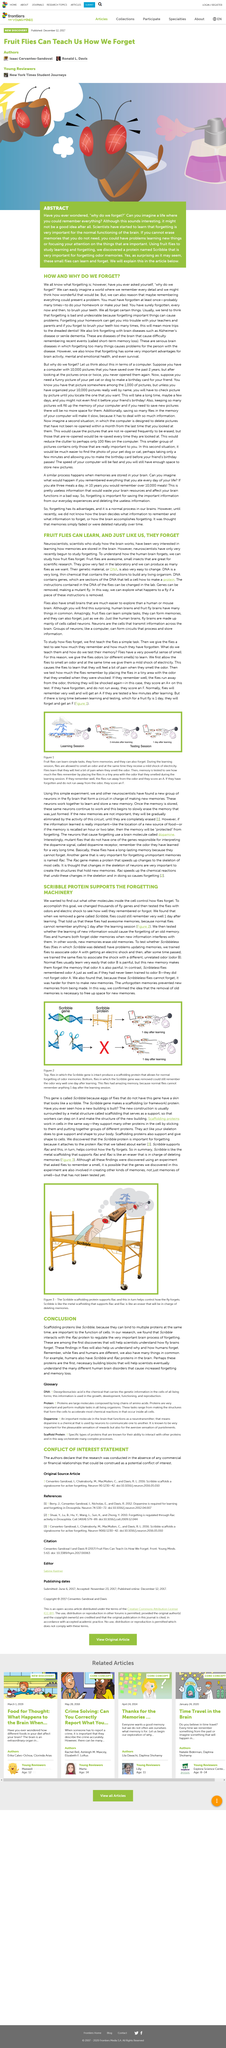Point out several critical features in this image. Scientists have been studying fruit flies as part of their research on a particular insect. Scientists are studying fruit flies due to their ease of cultivation and the extensive length of their DNA. Scientists are experimenting on fruit flies to determine the effects of removing certain pieces of instructions. Scribble protein is the name of a protein that plays a crucial role in forgetting odor memories. Scribble is a scaffolding protein that is able to bind to multiple proteins simultaneously, as explained in the article. 